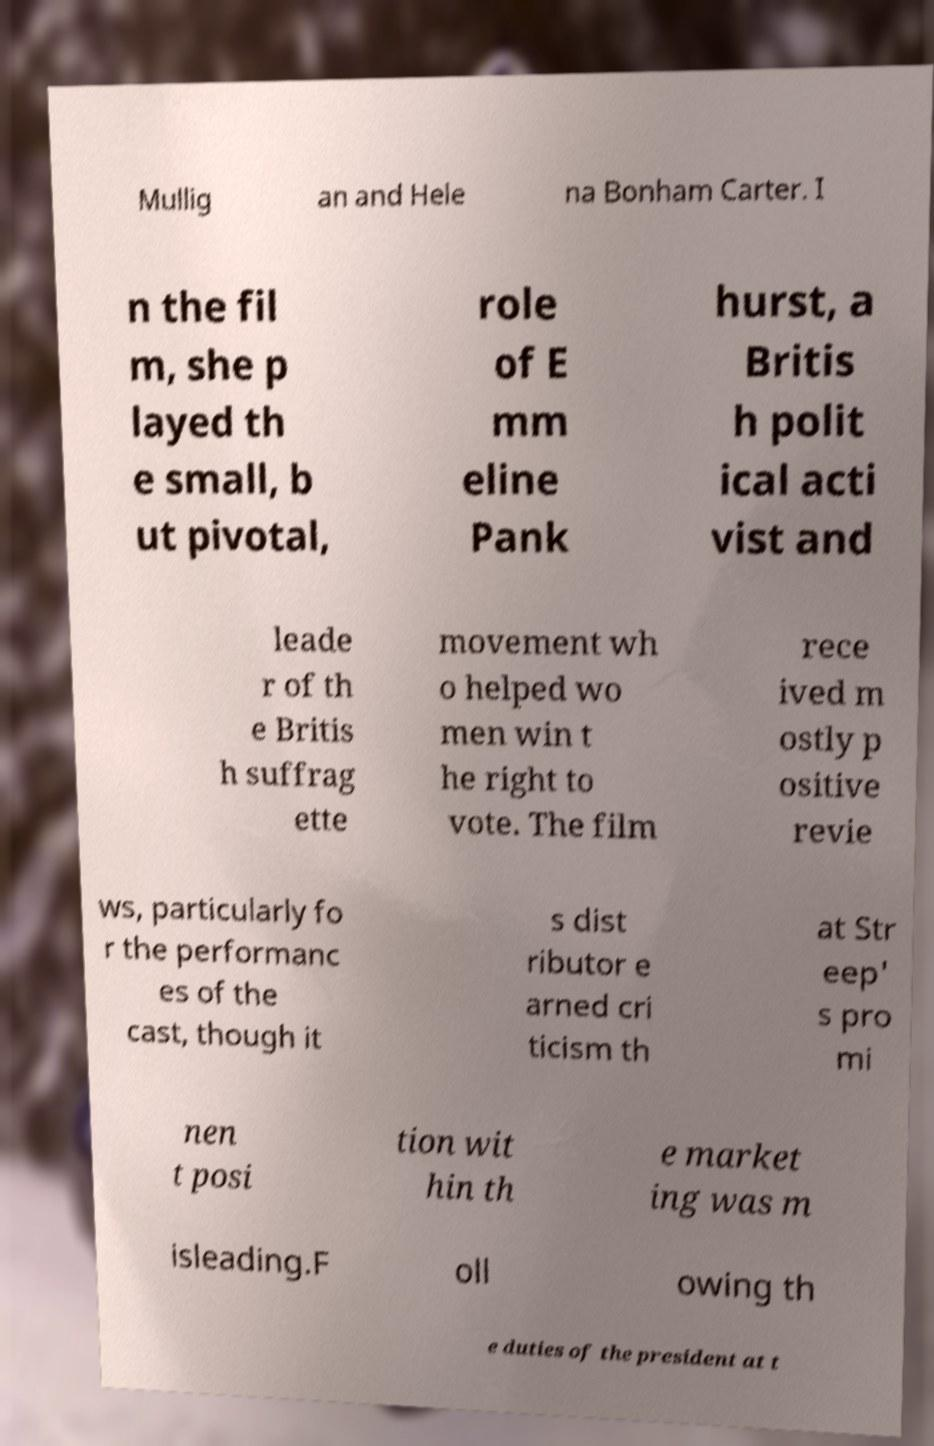Could you extract and type out the text from this image? Mullig an and Hele na Bonham Carter. I n the fil m, she p layed th e small, b ut pivotal, role of E mm eline Pank hurst, a Britis h polit ical acti vist and leade r of th e Britis h suffrag ette movement wh o helped wo men win t he right to vote. The film rece ived m ostly p ositive revie ws, particularly fo r the performanc es of the cast, though it s dist ributor e arned cri ticism th at Str eep' s pro mi nen t posi tion wit hin th e market ing was m isleading.F oll owing th e duties of the president at t 